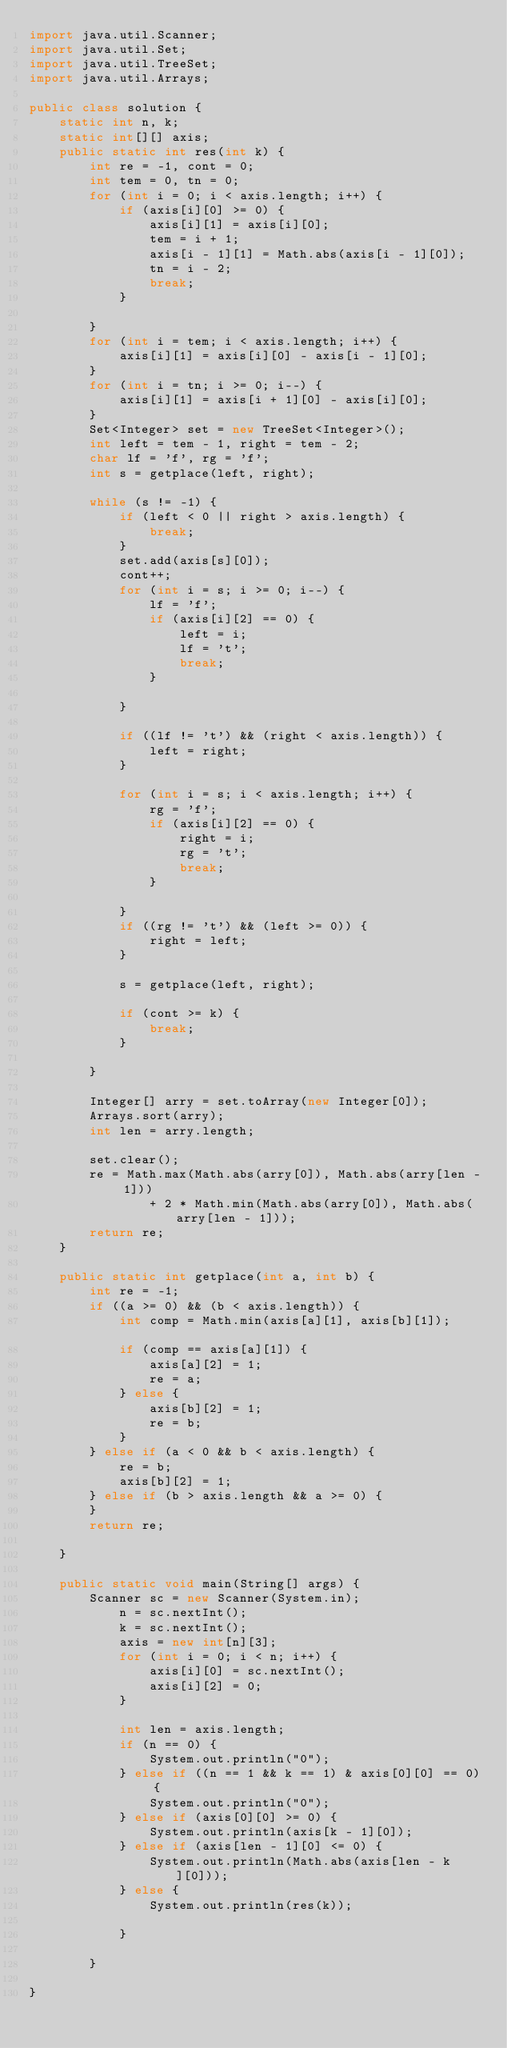Convert code to text. <code><loc_0><loc_0><loc_500><loc_500><_Java_>import java.util.Scanner;
import java.util.Set;
import java.util.TreeSet;
import java.util.Arrays;

public class solution {
	static int n, k;
	static int[][] axis;	
	public static int res(int k) {
		int re = -1, cont = 0;
		int tem = 0, tn = 0;
		for (int i = 0; i < axis.length; i++) {
			if (axis[i][0] >= 0) {
				axis[i][1] = axis[i][0];
				tem = i + 1;
				axis[i - 1][1] = Math.abs(axis[i - 1][0]);
				tn = i - 2;
				break;
			}

		}
		for (int i = tem; i < axis.length; i++) {
			axis[i][1] = axis[i][0] - axis[i - 1][0];
		}
		for (int i = tn; i >= 0; i--) {
			axis[i][1] = axis[i + 1][0] - axis[i][0];
		}
		Set<Integer> set = new TreeSet<Integer>();
		int left = tem - 1, right = tem - 2;
		char lf = 'f', rg = 'f';
		int s = getplace(left, right);

		while (s != -1) {
			if (left < 0 || right > axis.length) {
				break;
			}
			set.add(axis[s][0]);		
			cont++;
			for (int i = s; i >= 0; i--) {
				lf = 'f';
				if (axis[i][2] == 0) {
					left = i;
					lf = 't';
					break;
				}

			}

			if ((lf != 't') && (right < axis.length)) {
				left = right;				
			}

			for (int i = s; i < axis.length; i++) {
				rg = 'f';
				if (axis[i][2] == 0) {
					right = i;
					rg = 't';
					break;
				}

			}
			if ((rg != 't') && (left >= 0)) {
				right = left;				
			}

			s = getplace(left, right);

			if (cont >= k) {
				break;
			}

		}

		Integer[] arry = set.toArray(new Integer[0]);
		Arrays.sort(arry);
		int len = arry.length;

		set.clear();
		re = Math.max(Math.abs(arry[0]), Math.abs(arry[len - 1]))
				+ 2 * Math.min(Math.abs(arry[0]), Math.abs(arry[len - 1]));
		return re;
	}

	public static int getplace(int a, int b) {
		int re = -1;
		if ((a >= 0) && (b < axis.length)) {
			int comp = Math.min(axis[a][1], axis[b][1]);			
			if (comp == axis[a][1]) {
				axis[a][2] = 1;
				re = a;
			} else {
				axis[b][2] = 1;
				re = b;
			}
		} else if (a < 0 && b < axis.length) {
			re = b;
			axis[b][2] = 1;
		} else if (b > axis.length && a >= 0) {
		}
		return re;

	}

	public static void main(String[] args) {	
		Scanner sc = new Scanner(System.in);		
			n = sc.nextInt();
			k = sc.nextInt();			
			axis = new int[n][3];
			for (int i = 0; i < n; i++) {
				axis[i][0] = sc.nextInt();				
				axis[i][2] = 0;
			}
			
			int len = axis.length;
			if (n == 0) {
				System.out.println("0");
			} else if ((n == 1 && k == 1) & axis[0][0] == 0) {
				System.out.println("0");
			} else if (axis[0][0] >= 0) {
				System.out.println(axis[k - 1][0]);
			} else if (axis[len - 1][0] <= 0) {
				System.out.println(Math.abs(axis[len - k][0]));
			} else {
				System.out.println(res(k));

			}

		}	

}
</code> 